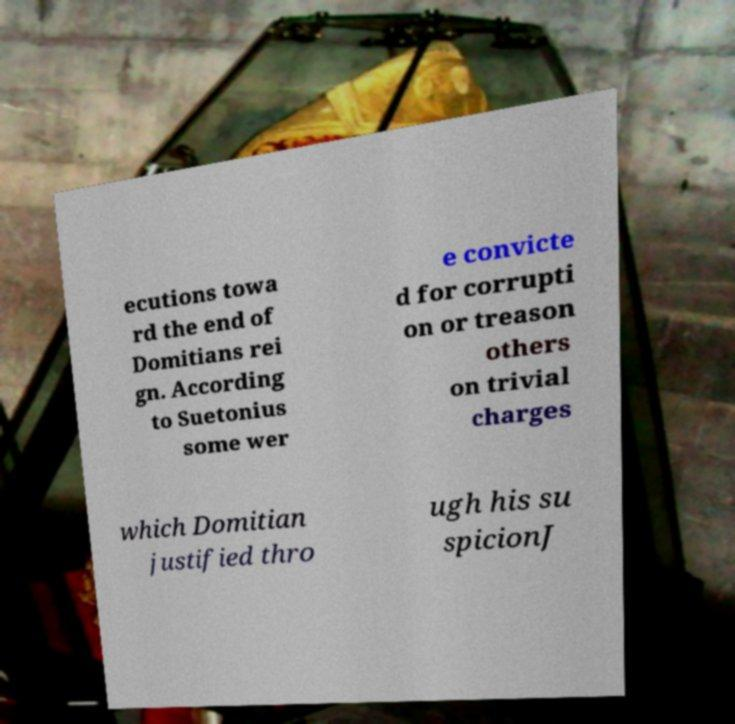What messages or text are displayed in this image? I need them in a readable, typed format. ecutions towa rd the end of Domitians rei gn. According to Suetonius some wer e convicte d for corrupti on or treason others on trivial charges which Domitian justified thro ugh his su spicionJ 